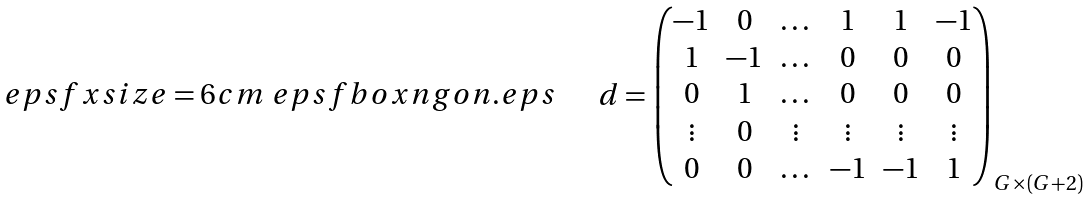<formula> <loc_0><loc_0><loc_500><loc_500>\begin{array} { l c l } \begin{array} { l } \ e p s f x s i z e = 6 c m \ e p s f b o x { n g o n . e p s } \end{array} & & d = \left ( \begin{matrix} - 1 & 0 & \dots & 1 & 1 & - 1 \\ 1 & - 1 & \dots & 0 & 0 & 0 \\ 0 & 1 & \dots & 0 & 0 & 0 \\ \vdots & 0 & \vdots & \vdots & \vdots & \vdots \\ 0 & 0 & \dots & - 1 & - 1 & 1 \\ \end{matrix} \right ) _ { G \times ( G + 2 ) } \end{array}</formula> 